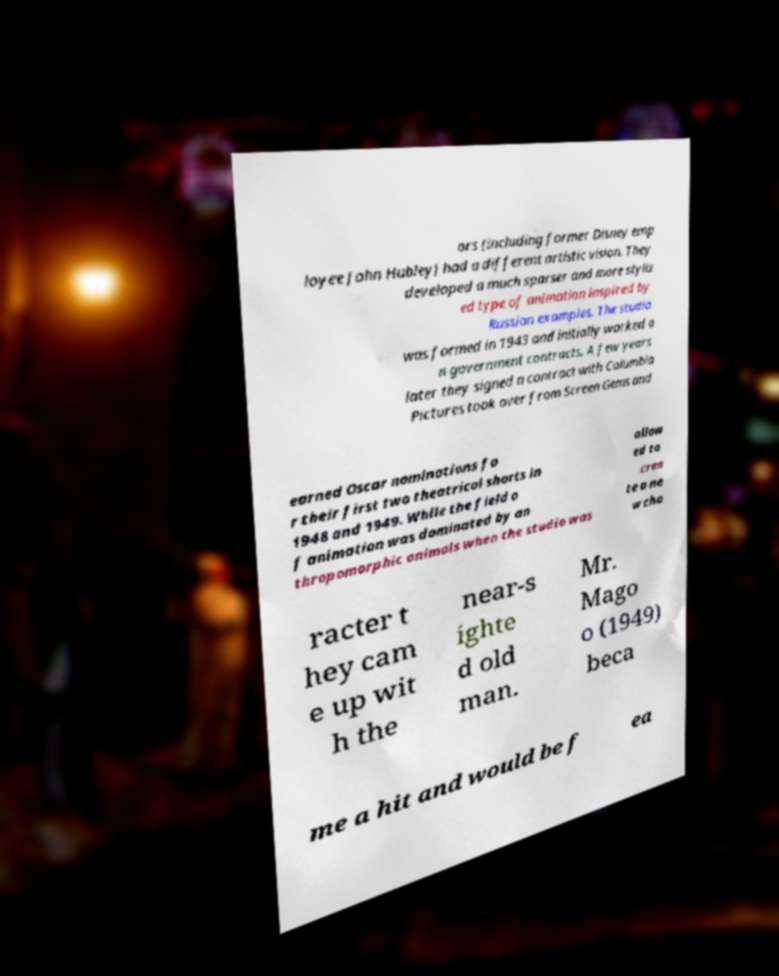Could you extract and type out the text from this image? ors (including former Disney emp loyee John Hubley) had a different artistic vision. They developed a much sparser and more styliz ed type of animation inspired by Russian examples. The studio was formed in 1943 and initially worked o n government contracts. A few years later they signed a contract with Columbia Pictures took over from Screen Gems and earned Oscar nominations fo r their first two theatrical shorts in 1948 and 1949. While the field o f animation was dominated by an thropomorphic animals when the studio was allow ed to crea te a ne w cha racter t hey cam e up wit h the near-s ighte d old man. Mr. Mago o (1949) beca me a hit and would be f ea 